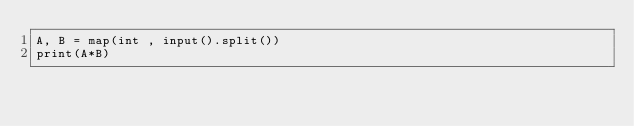Convert code to text. <code><loc_0><loc_0><loc_500><loc_500><_Python_>A, B = map(int , input().split())
print(A*B)</code> 